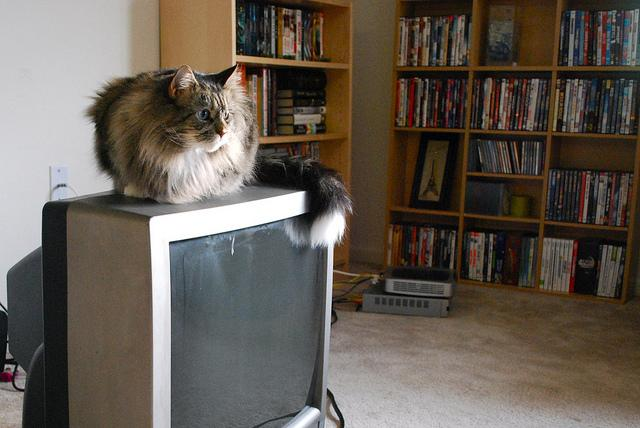What is the item that the cat is on top of used for?

Choices:
A) writing books
B) storing groceries
C) watching shows
D) cleaning floors watching shows 